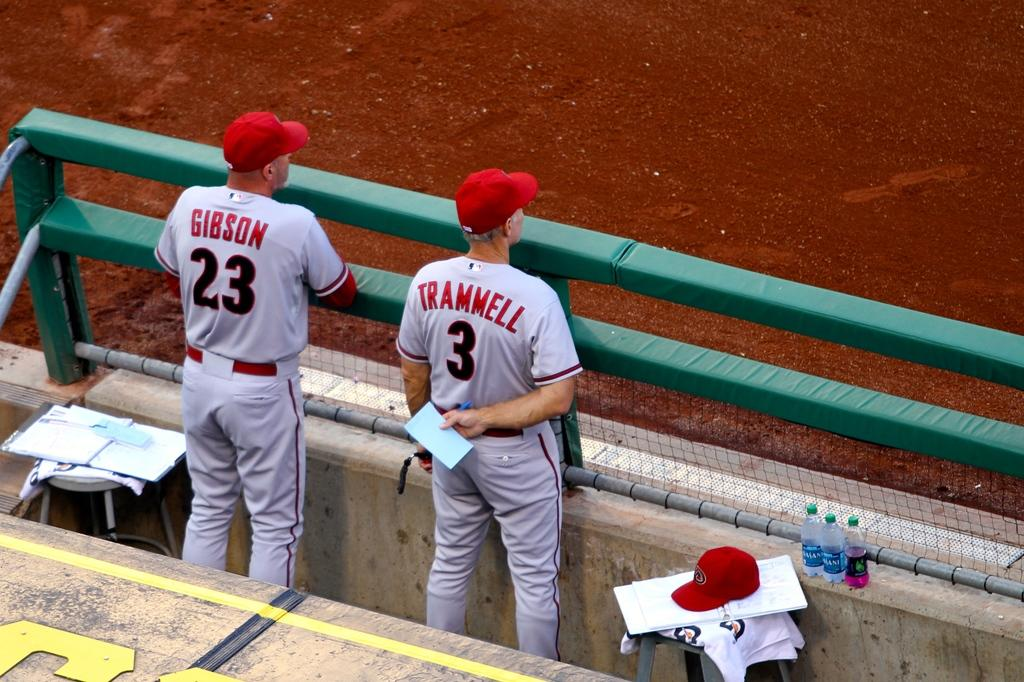<image>
Share a concise interpretation of the image provided. Baseball coaches wearing number 3 and 23 observe the game from the dugout. 